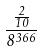Convert formula to latex. <formula><loc_0><loc_0><loc_500><loc_500>\frac { \frac { 2 } { 1 0 } } { 8 ^ { 3 6 6 } }</formula> 